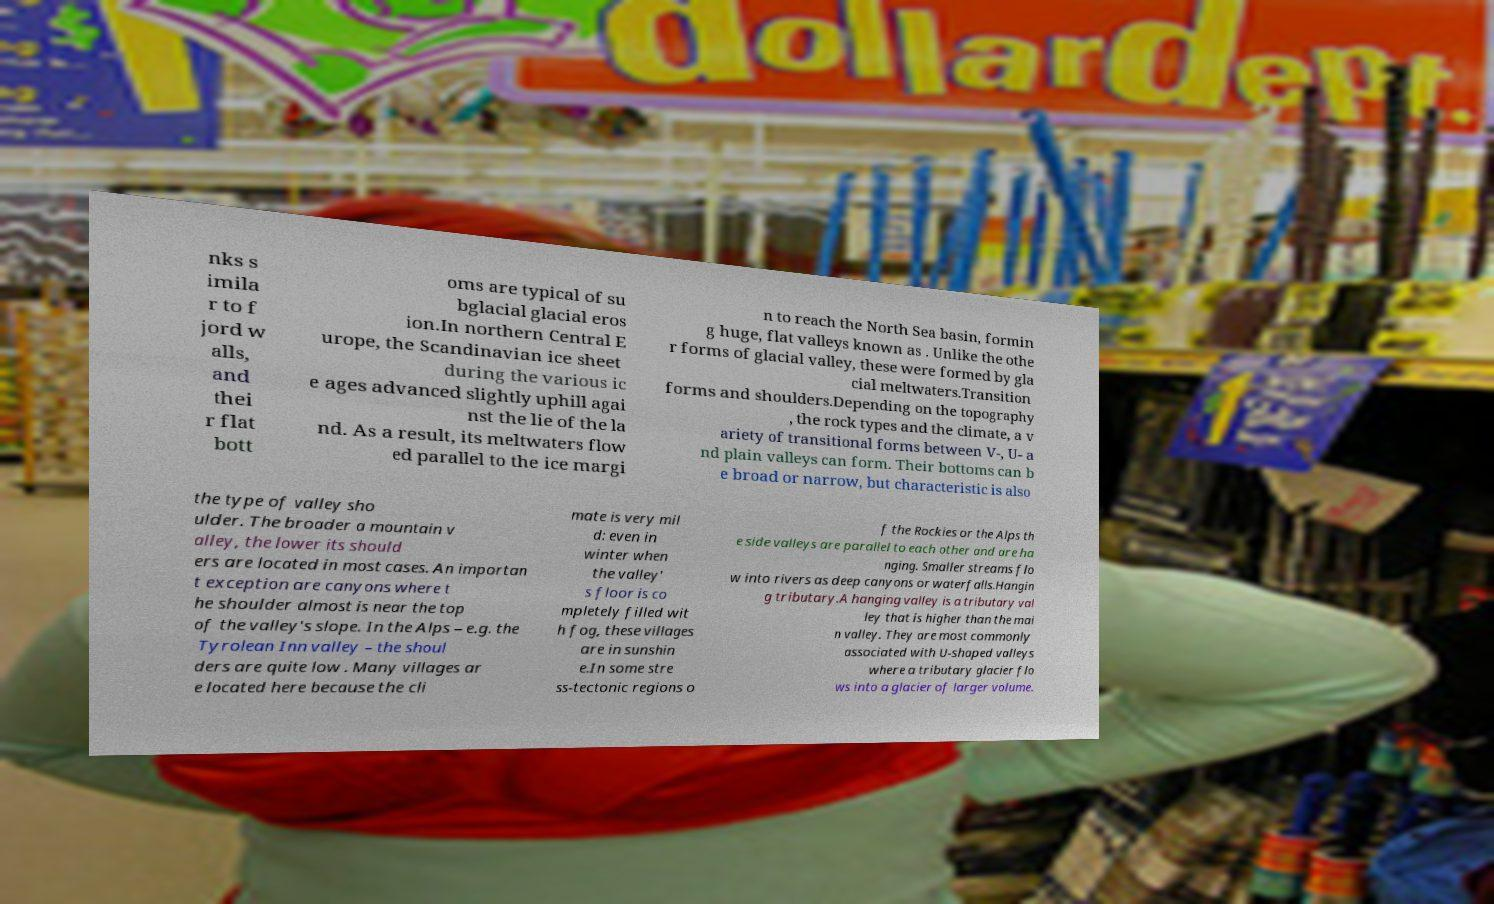There's text embedded in this image that I need extracted. Can you transcribe it verbatim? nks s imila r to f jord w alls, and thei r flat bott oms are typical of su bglacial glacial eros ion.In northern Central E urope, the Scandinavian ice sheet during the various ic e ages advanced slightly uphill agai nst the lie of the la nd. As a result, its meltwaters flow ed parallel to the ice margi n to reach the North Sea basin, formin g huge, flat valleys known as . Unlike the othe r forms of glacial valley, these were formed by gla cial meltwaters.Transition forms and shoulders.Depending on the topography , the rock types and the climate, a v ariety of transitional forms between V-, U- a nd plain valleys can form. Their bottoms can b e broad or narrow, but characteristic is also the type of valley sho ulder. The broader a mountain v alley, the lower its should ers are located in most cases. An importan t exception are canyons where t he shoulder almost is near the top of the valley's slope. In the Alps – e.g. the Tyrolean Inn valley – the shoul ders are quite low . Many villages ar e located here because the cli mate is very mil d: even in winter when the valley' s floor is co mpletely filled wit h fog, these villages are in sunshin e.In some stre ss-tectonic regions o f the Rockies or the Alps th e side valleys are parallel to each other and are ha nging. Smaller streams flo w into rivers as deep canyons or waterfalls.Hangin g tributary.A hanging valley is a tributary val ley that is higher than the mai n valley. They are most commonly associated with U-shaped valleys where a tributary glacier flo ws into a glacier of larger volume. 